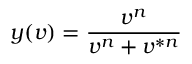Convert formula to latex. <formula><loc_0><loc_0><loc_500><loc_500>y ( v ) = \frac { v ^ { n } } { v ^ { n } + v ^ { \ast n } }</formula> 